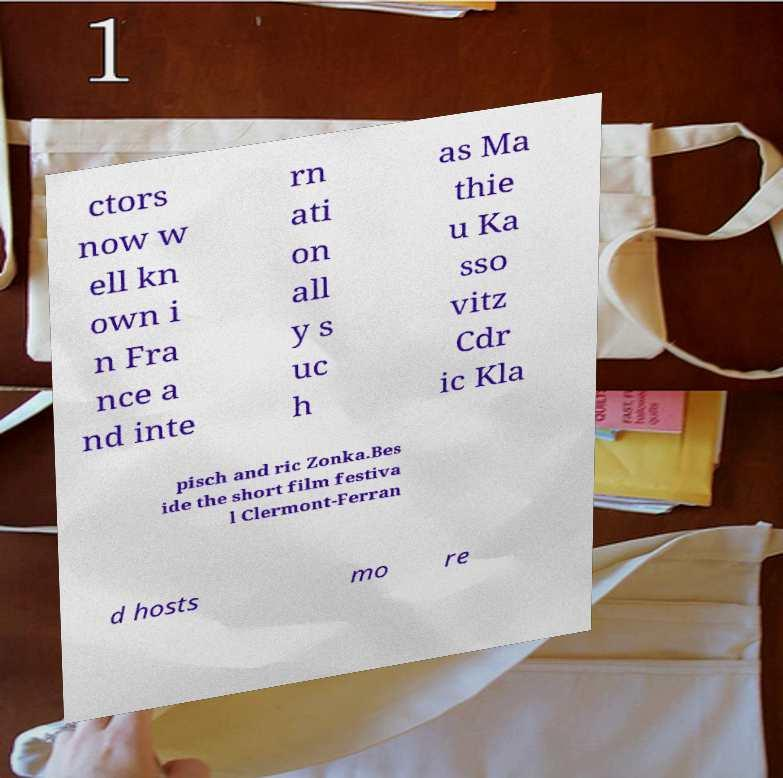Please read and relay the text visible in this image. What does it say? ctors now w ell kn own i n Fra nce a nd inte rn ati on all y s uc h as Ma thie u Ka sso vitz Cdr ic Kla pisch and ric Zonka.Bes ide the short film festiva l Clermont-Ferran d hosts mo re 